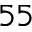Convert formula to latex. <formula><loc_0><loc_0><loc_500><loc_500>^ { 5 5 }</formula> 